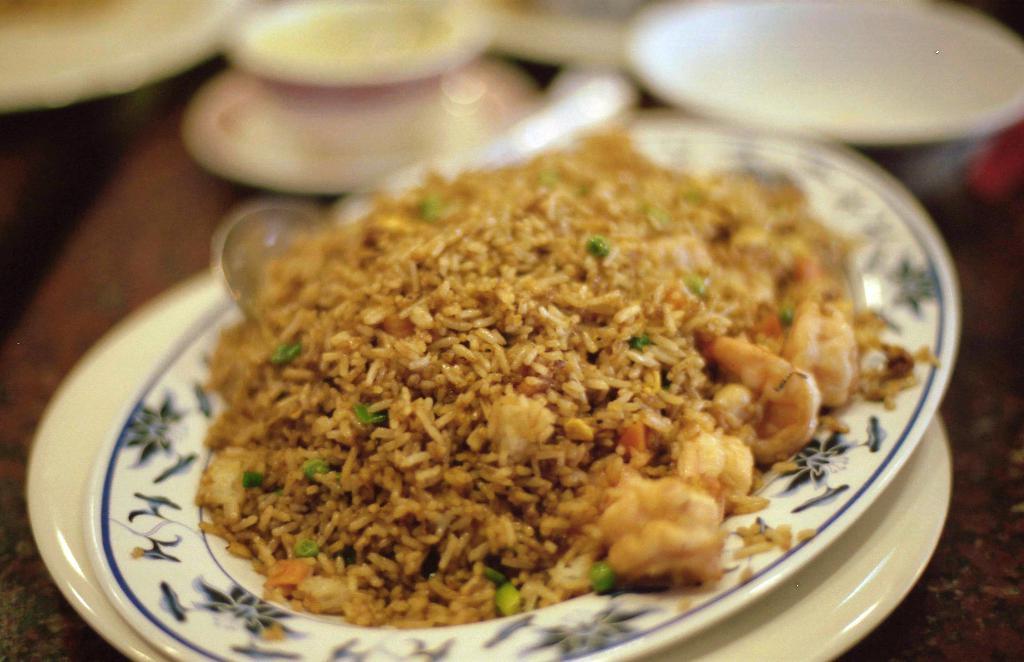Describe this image in one or two sentences. In this image we can see a table and on the table there is a serving plate with food on it. 